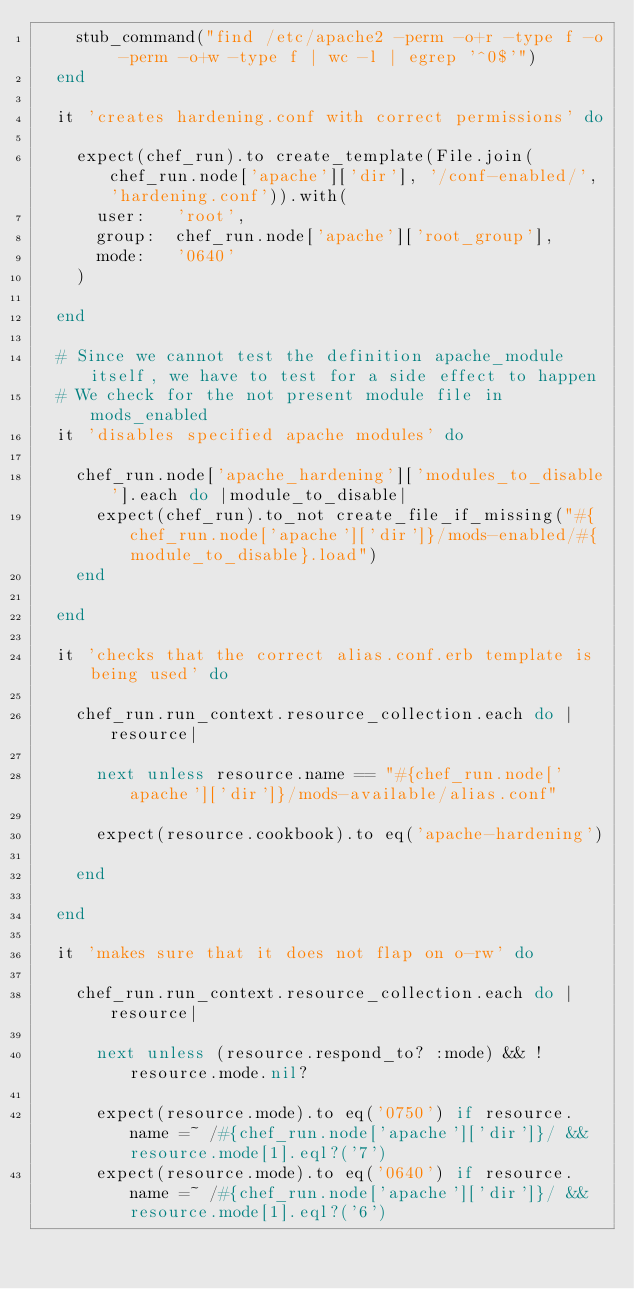Convert code to text. <code><loc_0><loc_0><loc_500><loc_500><_Ruby_>    stub_command("find /etc/apache2 -perm -o+r -type f -o -perm -o+w -type f | wc -l | egrep '^0$'")
  end

  it 'creates hardening.conf with correct permissions' do

    expect(chef_run).to create_template(File.join(chef_run.node['apache']['dir'], '/conf-enabled/', 'hardening.conf')).with(
      user:   'root',
      group:  chef_run.node['apache']['root_group'],
      mode:   '0640'
    )

  end

  # Since we cannot test the definition apache_module itself, we have to test for a side effect to happen
  # We check for the not present module file in mods_enabled
  it 'disables specified apache modules' do

    chef_run.node['apache_hardening']['modules_to_disable'].each do |module_to_disable|
      expect(chef_run).to_not create_file_if_missing("#{chef_run.node['apache']['dir']}/mods-enabled/#{module_to_disable}.load")
    end

  end

  it 'checks that the correct alias.conf.erb template is being used' do

    chef_run.run_context.resource_collection.each do |resource|

      next unless resource.name == "#{chef_run.node['apache']['dir']}/mods-available/alias.conf"

      expect(resource.cookbook).to eq('apache-hardening')

    end

  end

  it 'makes sure that it does not flap on o-rw' do

    chef_run.run_context.resource_collection.each do |resource|

      next unless (resource.respond_to? :mode) && !resource.mode.nil?

      expect(resource.mode).to eq('0750') if resource.name =~ /#{chef_run.node['apache']['dir']}/ && resource.mode[1].eql?('7')
      expect(resource.mode).to eq('0640') if resource.name =~ /#{chef_run.node['apache']['dir']}/ && resource.mode[1].eql?('6')</code> 